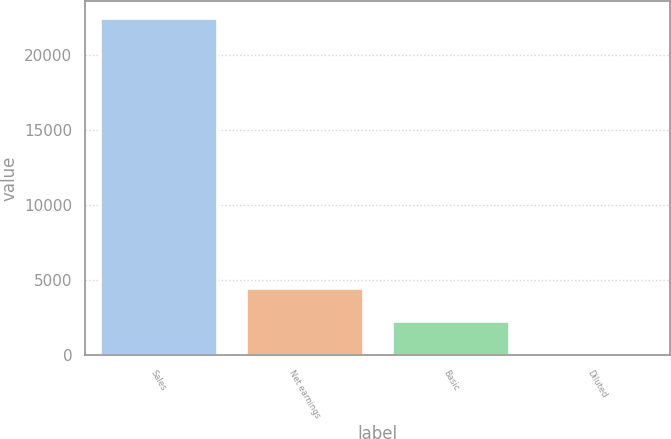<chart> <loc_0><loc_0><loc_500><loc_500><bar_chart><fcel>Sales<fcel>Net earnings<fcel>Basic<fcel>Diluted<nl><fcel>22470<fcel>4494.65<fcel>2247.73<fcel>0.81<nl></chart> 